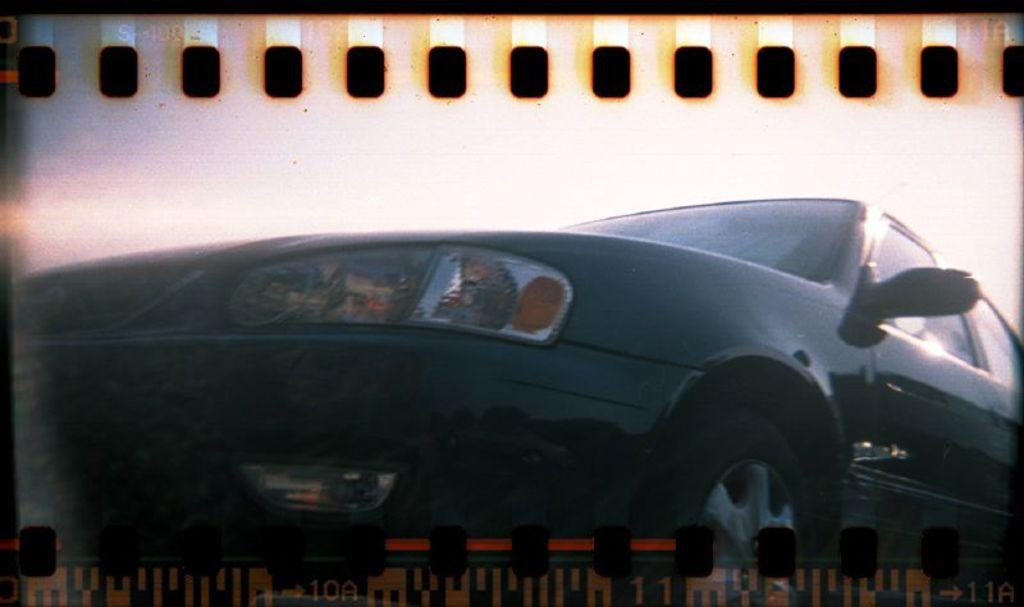What is the main object in the image? There is a screen in the image. What is being displayed on the screen? A car is visible on the screen. What else can be seen on the screen besides the car? The sky is visible on the screen. Where is the playground located in the image? There is no playground present in the image; it only features a screen with a car and the sky displayed. 